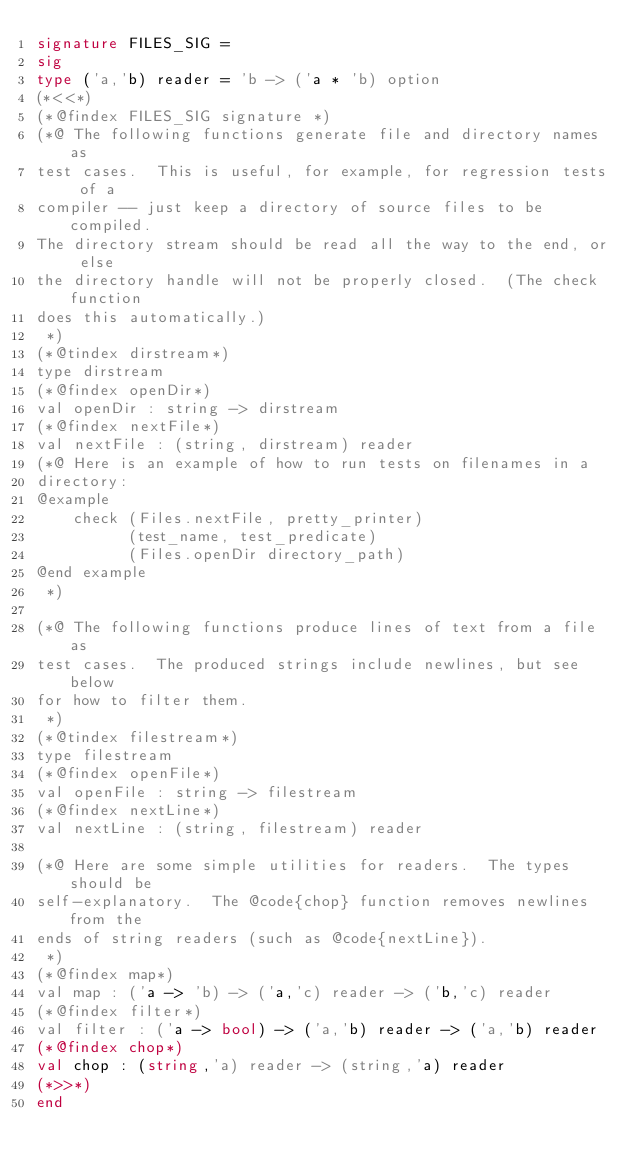Convert code to text. <code><loc_0><loc_0><loc_500><loc_500><_SML_>signature FILES_SIG =
sig 
type ('a,'b) reader = 'b -> ('a * 'b) option
(*<<*)
(*@findex FILES_SIG signature *)
(*@ The following functions generate file and directory names as 
test cases.  This is useful, for example, for regression tests of a 
compiler -- just keep a directory of source files to be compiled.
The directory stream should be read all the way to the end, or else
the directory handle will not be properly closed.  (The check function
does this automatically.)
 *)
(*@tindex dirstream*)
type dirstream                              
(*@findex openDir*)
val openDir : string -> dirstream           
(*@findex nextFile*)
val nextFile : (string, dirstream) reader   
(*@ Here is an example of how to run tests on filenames in a 
directory:
@example
    check (Files.nextFile, pretty_printer)
          (test_name, test_predicate)
          (Files.openDir directory_path)
@end example
 *)

(*@ The following functions produce lines of text from a file as
test cases.  The produced strings include newlines, but see below 
for how to filter them.
 *)
(*@tindex filestream*)
type filestream                             
(*@findex openFile*)
val openFile : string -> filestream         
(*@findex nextLine*)
val nextLine : (string, filestream) reader  

(*@ Here are some simple utilities for readers.  The types should be 
self-explanatory.  The @code{chop} function removes newlines from the 
ends of string readers (such as @code{nextLine}).
 *)
(*@findex map*)
val map : ('a -> 'b) -> ('a,'c) reader -> ('b,'c) reader 
(*@findex filter*)
val filter : ('a -> bool) -> ('a,'b) reader -> ('a,'b) reader 
(*@findex chop*)
val chop : (string,'a) reader -> (string,'a) reader 
(*>>*)
end
</code> 